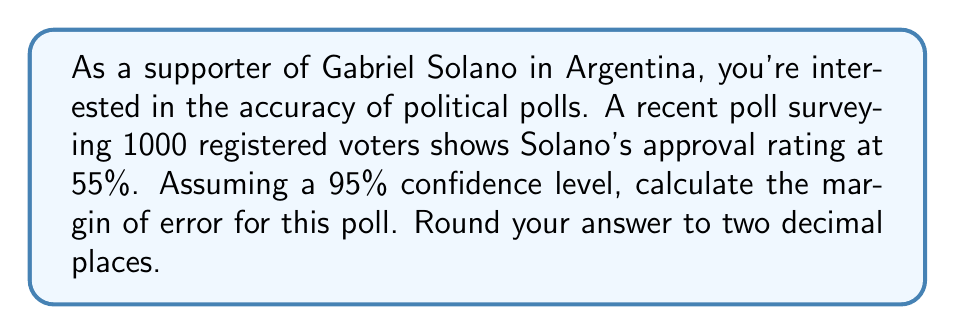Help me with this question. To calculate the margin of error for this political poll, we'll follow these steps:

1. Identify the given information:
   - Sample size (n) = 1000
   - Confidence level = 95%
   - Estimated proportion (p) = 55% = 0.55

2. Determine the z-score for a 95% confidence level:
   The z-score for a 95% confidence level is 1.96.

3. Calculate the standard error of the proportion:
   $$ SE = \sqrt{\frac{p(1-p)}{n}} $$
   $$ SE = \sqrt{\frac{0.55(1-0.55)}{1000}} = \sqrt{\frac{0.2475}{1000}} = 0.01573 $$

4. Calculate the margin of error:
   $$ ME = z \times SE $$
   $$ ME = 1.96 \times 0.01573 = 0.03083 $$

5. Convert to percentage and round to two decimal places:
   $$ ME = 0.03083 \times 100\% = 3.083\% \approx 3.08\% $$

This means that we can be 95% confident that the true approval rating for Gabriel Solano is within ±3.08 percentage points of the poll result.
Answer: 3.08% 